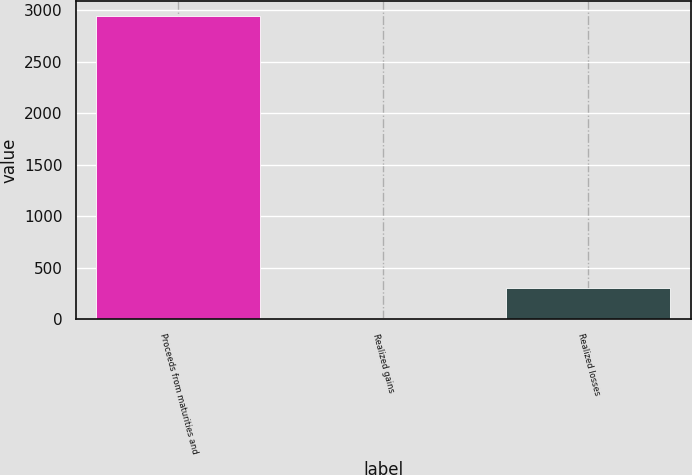Convert chart to OTSL. <chart><loc_0><loc_0><loc_500><loc_500><bar_chart><fcel>Proceeds from maturities and<fcel>Realized gains<fcel>Realized losses<nl><fcel>2941.1<fcel>15.9<fcel>308.42<nl></chart> 